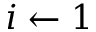<formula> <loc_0><loc_0><loc_500><loc_500>i \gets 1</formula> 